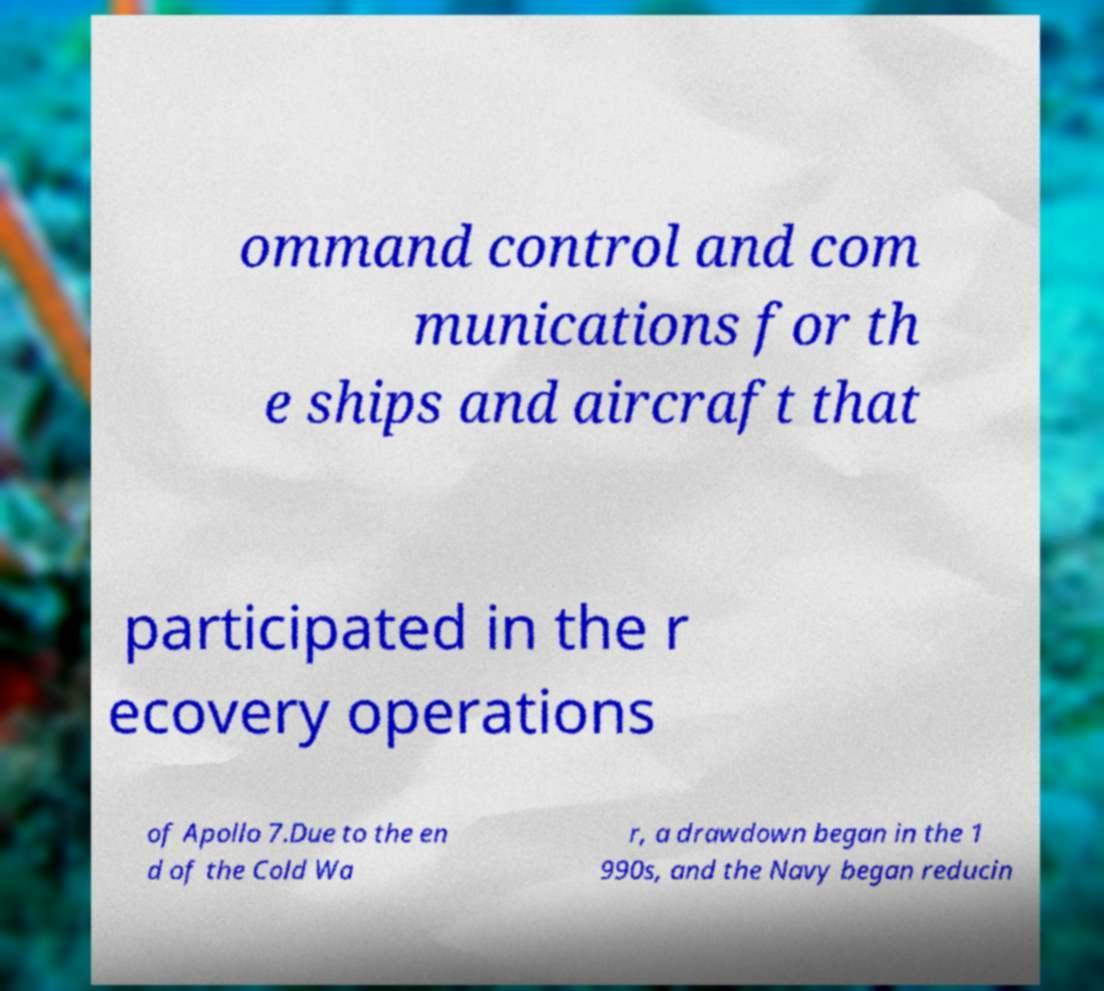There's text embedded in this image that I need extracted. Can you transcribe it verbatim? ommand control and com munications for th e ships and aircraft that participated in the r ecovery operations of Apollo 7.Due to the en d of the Cold Wa r, a drawdown began in the 1 990s, and the Navy began reducin 